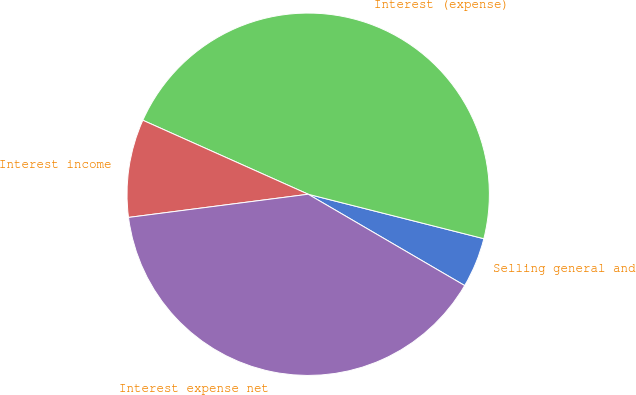Convert chart. <chart><loc_0><loc_0><loc_500><loc_500><pie_chart><fcel>Selling general and<fcel>Interest (expense)<fcel>Interest income<fcel>Interest expense net<nl><fcel>4.46%<fcel>47.25%<fcel>8.74%<fcel>39.55%<nl></chart> 